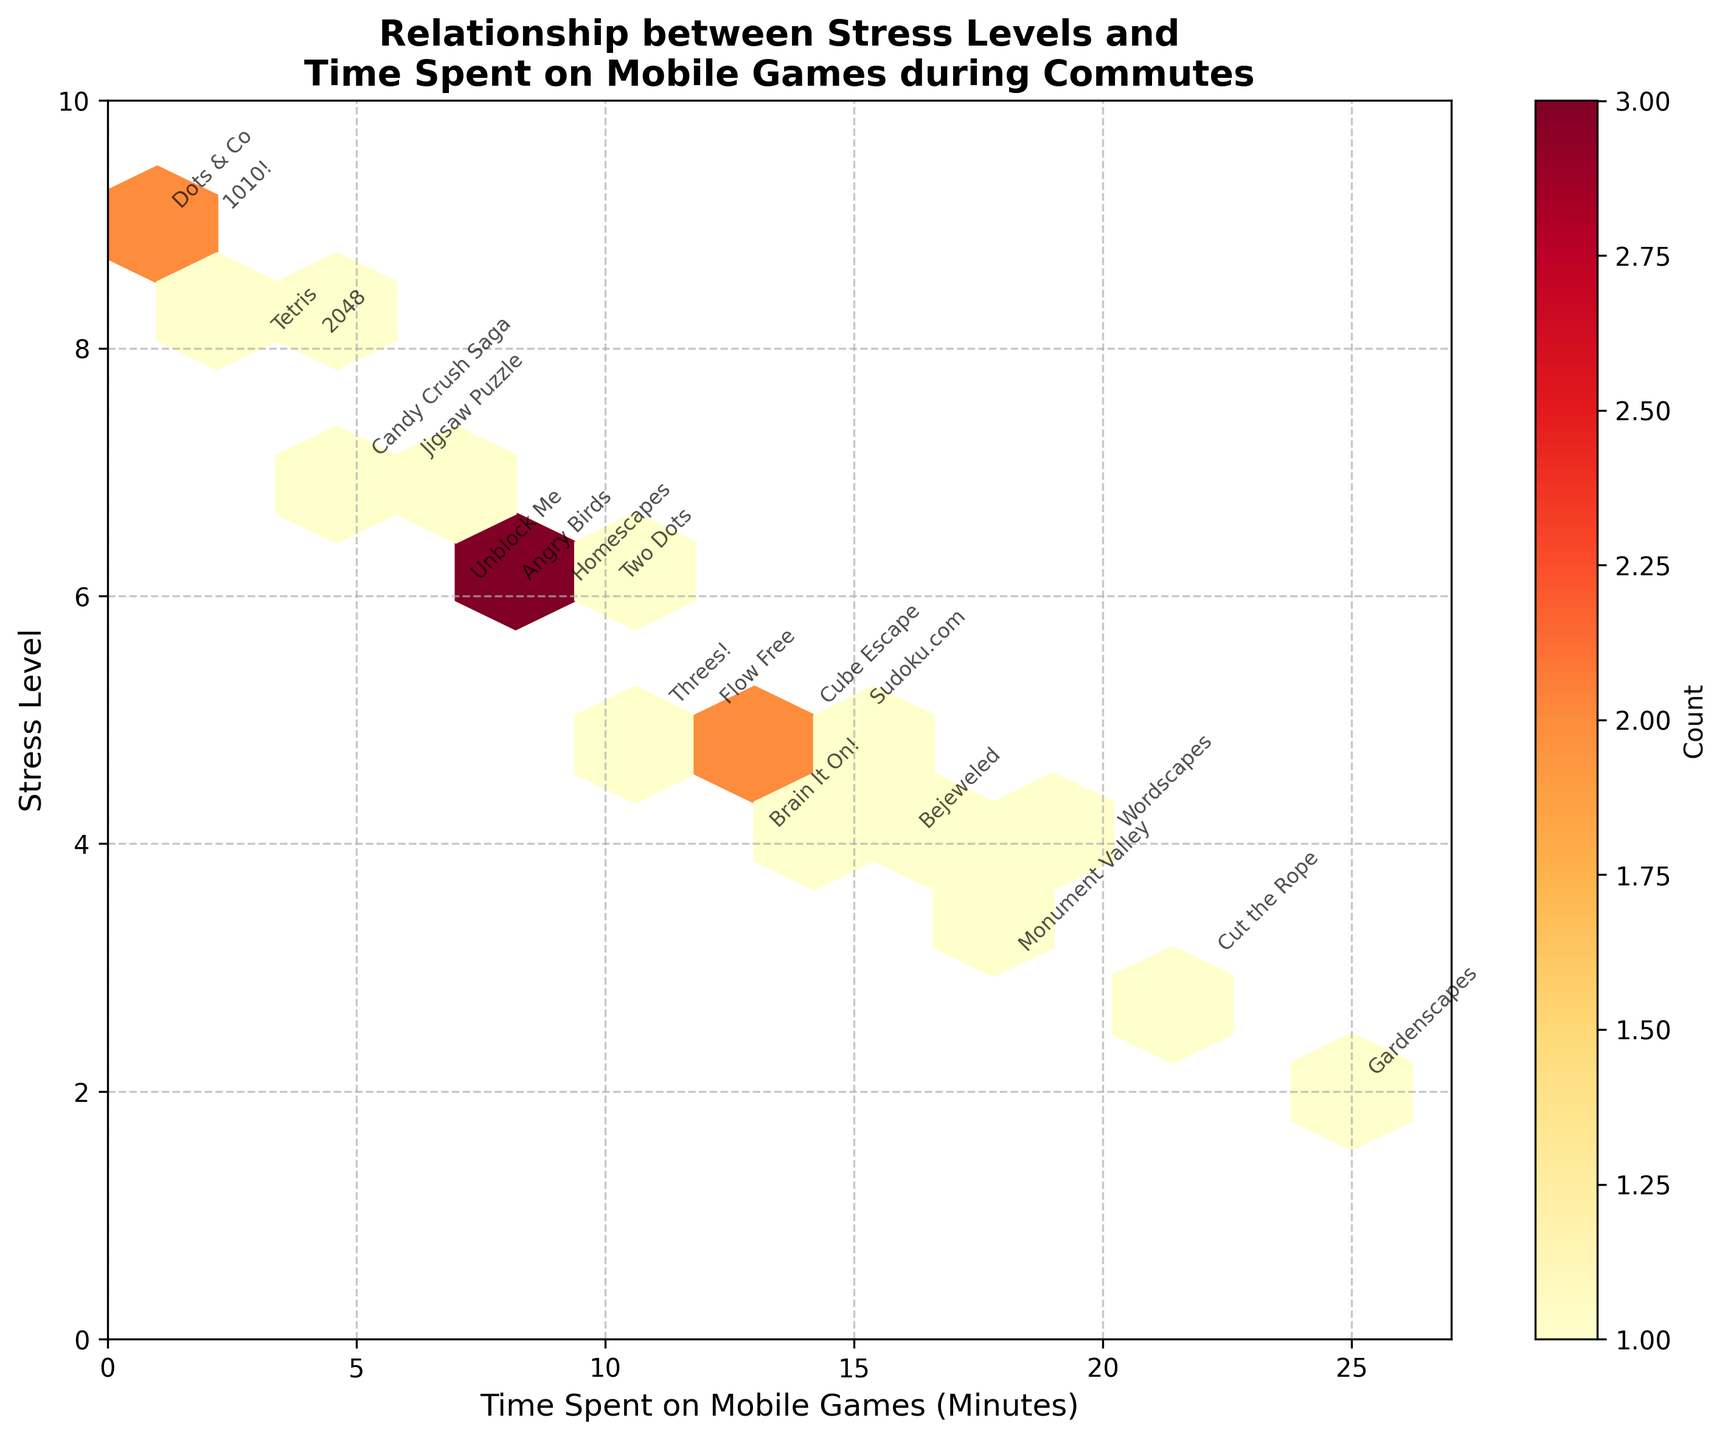What is the title of the plot? The title of the plot is displayed at the top and reads: "Relationship between Stress Levels and Time Spent on Mobile Games during Commutes."
Answer: Relationship between Stress Levels and Time Spent on Mobile Games during Commutes What do the colors in the hexagons represent? The colors in the hexagons represent the count of data points within each hexagon, with a color scale provided by the color bar on the side.
Answer: Count of data points Which game had the minimum time spent and what was its corresponding stress level? By examining the annotations, "Dots & Co" had the minimum time spent at 1 minute, with a corresponding stress level of 9.
Answer: Dots & Co, 9 What is the hexbin color for most concentrated areas represented? Check the color bar and find the maximum value color (dark red). The most concentrated areas are represented by this color.
Answer: Dark red What is the average stress level for games that had a time spent of more than 15 minutes? Identify games with time spent > 15 minutes (Monument Valley, Gardenscapes, Cut the Rope) and average their stress levels: (3 + 2 + 3)/3 = 2.67.
Answer: 2.67 How does the stress level vary with time spent on mobile games? As the time spent on mobile games increases, the general trend shows that stress levels tend to decrease.
Answer: Stress level decreases What is the correlation between time spent on games and stress level? By observing the distribution pattern in the hexbin plot, if data points are more concentrated along the general downward sloping trend, it indicates a negative correlation.
Answer: Negative correlation Between which time intervals does the highest density of data points lie? Examine where the darkest red hexagons are concentrated. Often, annotations and color bar can help in identifying these intervals.
Answer: Between 5 and 10 minutes Which game has the highest stress level, and how long was it played? Look for the game annotation at the highest point on the stress level axis (2048, 1010!, Dots & Co) and check the time spent. 2048 corresponds to 4 minutes, 1010! corresponds to 2 minutes, and Dots & Co corresponds to 1 minute.
Answer: Dots & Co, 1 minute For which stress level range is there the most diversity in time spent playing games? Identify the stress level range where the hexagons cover the widest range on the time spent axis. This is generally visible through dispersion in the horizontal direction.
Answer: Stress level 5-6 